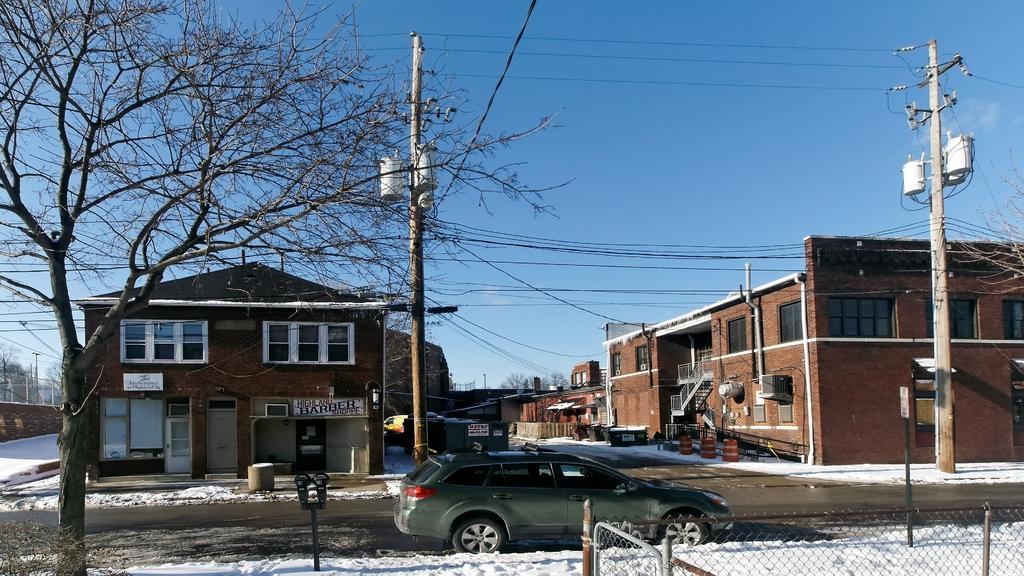How would you summarize this image in a sentence or two? In this image the land is covered with snow and car is moving on a road, in the background there are houses, current poles and the sky, on the left side there is a tree, on the bottom right there is fencing. 